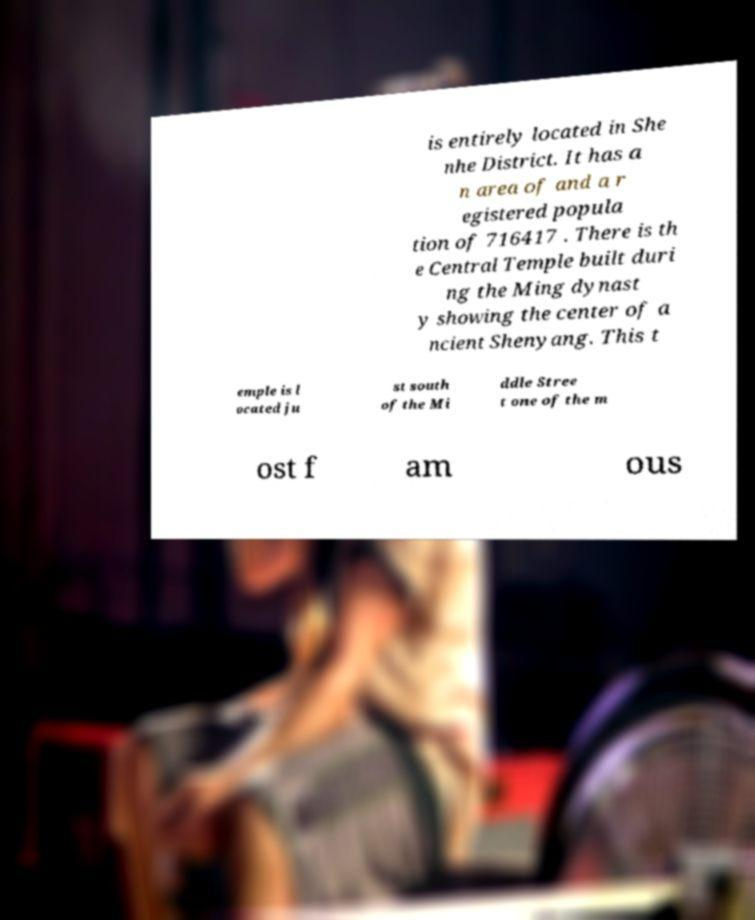Can you read and provide the text displayed in the image?This photo seems to have some interesting text. Can you extract and type it out for me? is entirely located in She nhe District. It has a n area of and a r egistered popula tion of 716417 . There is th e Central Temple built duri ng the Ming dynast y showing the center of a ncient Shenyang. This t emple is l ocated ju st south of the Mi ddle Stree t one of the m ost f am ous 